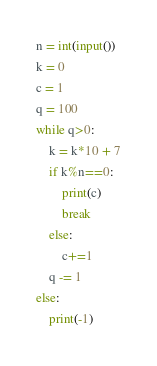<code> <loc_0><loc_0><loc_500><loc_500><_Python_>n = int(input())
k = 0
c = 1
q = 100
while q>0:
    k = k*10 + 7
    if k%n==0:
        print(c)
        break
    else:
        c+=1
    q -= 1
else:
    print(-1)</code> 